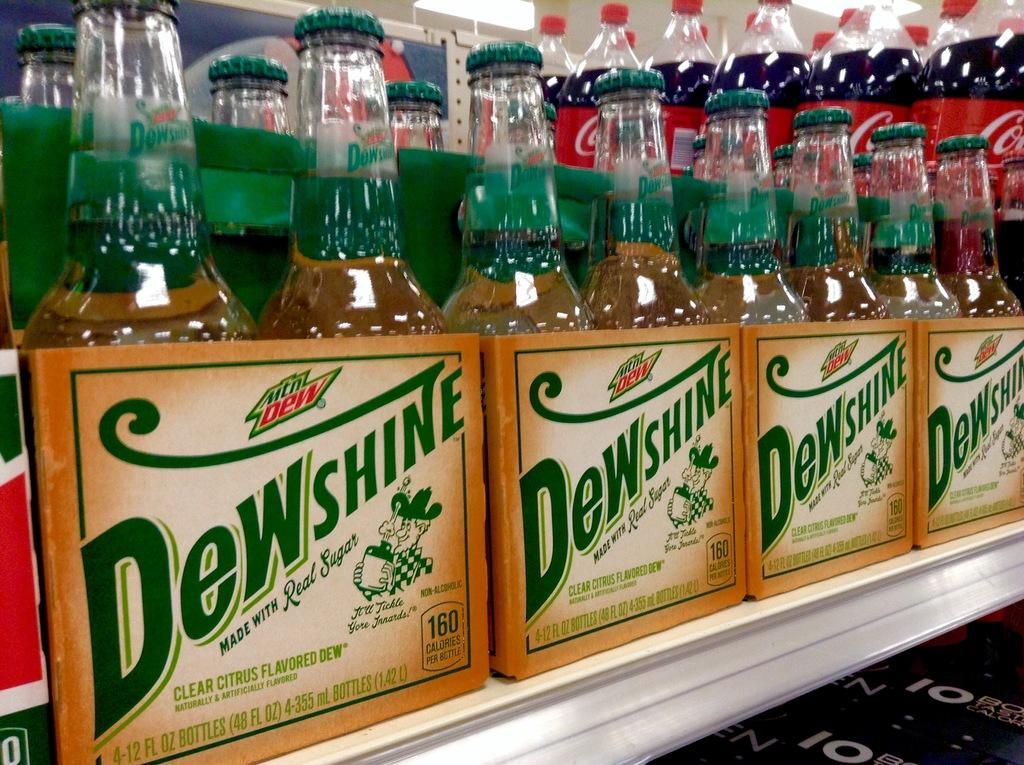What is the main subject of the image? The main subject of the image is many bottles. Where are the bottles located in the image? The bottles are in a box. Can you describe any other elements in the image? There is a light visible in the image. What type of wrench is being used to open the bottles in the image? There is no wrench present in the image, and the bottles are not being opened. 